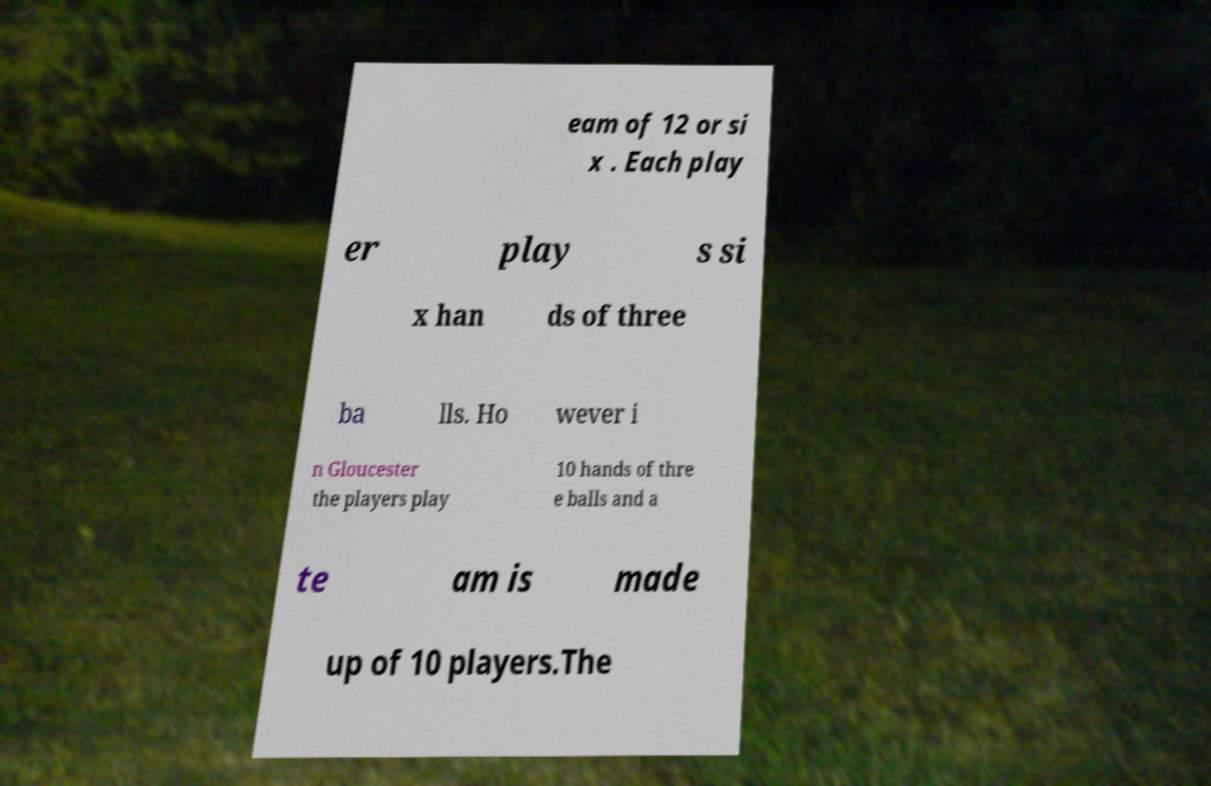Could you assist in decoding the text presented in this image and type it out clearly? eam of 12 or si x . Each play er play s si x han ds of three ba lls. Ho wever i n Gloucester the players play 10 hands of thre e balls and a te am is made up of 10 players.The 